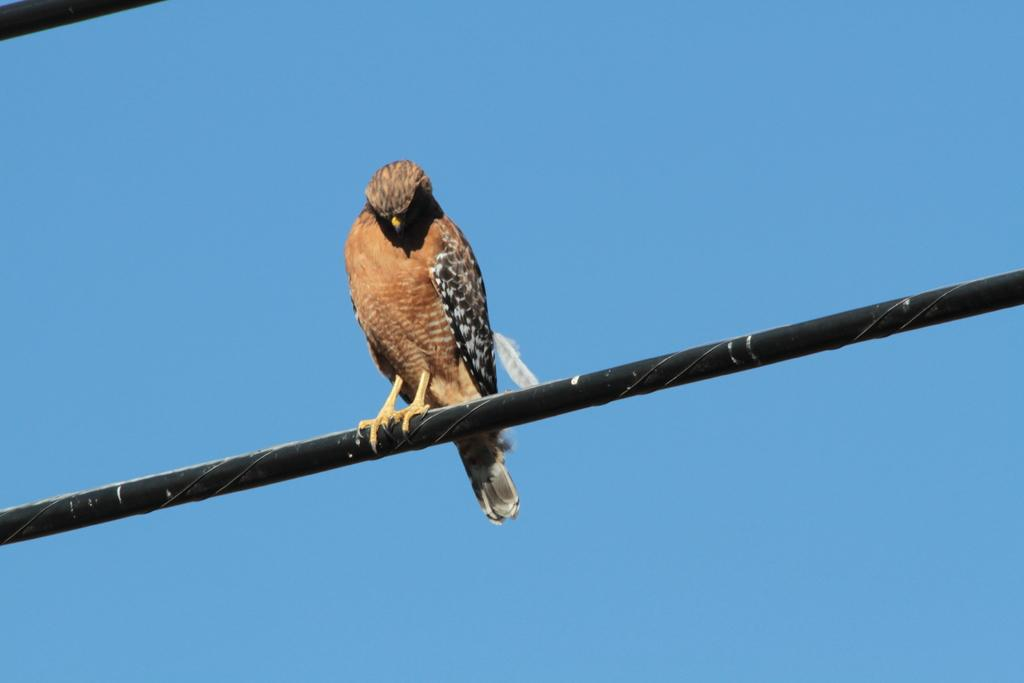What animal is present in the image? There is a bird in the image. Where is the bird positioned in the image? The bird is sitting on a rod. What is the color of the background in the image? The background color is blue. When was the image taken? The image was taken during the day. What type of cloth is draped over the bird in the image? There is no cloth present in the image; it only features a bird sitting on a rod with a blue background. 